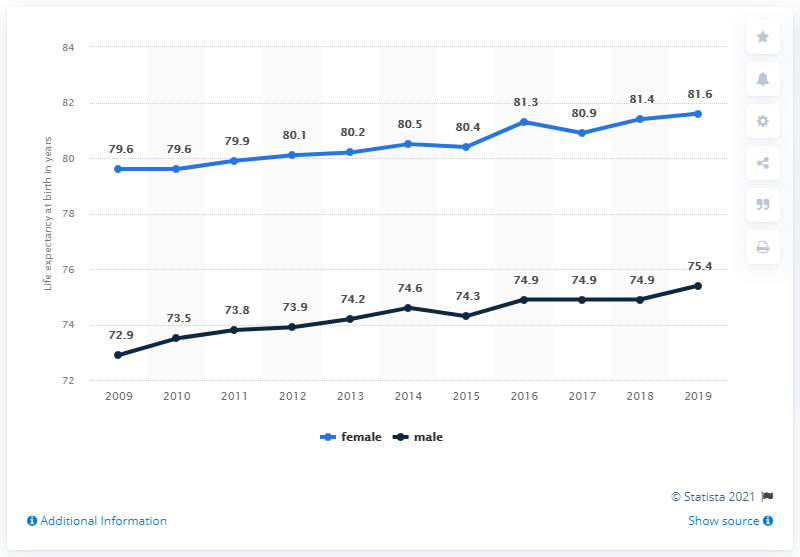Indicate a few pertinent items in this graphic. The life expectancy at birth in Croatia for a male in the year 2015 was 74.3 years. According to data from 2018, the average life expectancy at birth for males in Croatia was 6.5 years, while the average life expectancy for females was 7.5 years. 